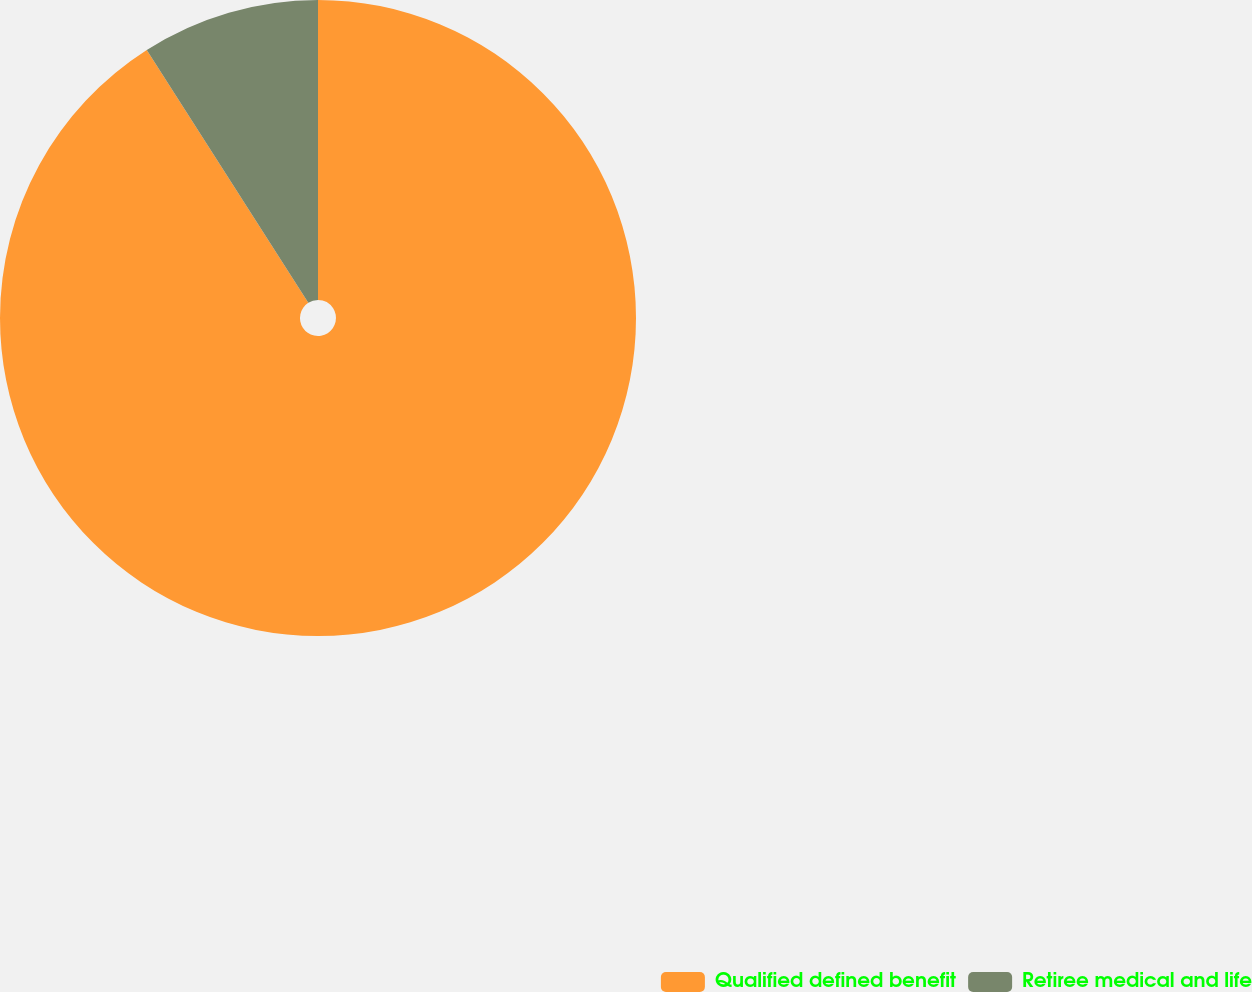<chart> <loc_0><loc_0><loc_500><loc_500><pie_chart><fcel>Qualified defined benefit<fcel>Retiree medical and life<nl><fcel>90.95%<fcel>9.05%<nl></chart> 